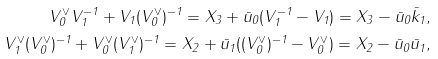<formula> <loc_0><loc_0><loc_500><loc_500>V _ { 0 } ^ { \vee } V _ { 1 } ^ { - 1 } + V _ { 1 } ( V _ { 0 } ^ { \vee } ) ^ { - 1 } = X _ { 3 } + \bar { u } _ { 0 } ( V _ { 1 } ^ { - 1 } - V _ { 1 } ) = X _ { 3 } - \bar { u } _ { 0 } \bar { k } _ { 1 } , \\ V _ { 1 } ^ { \vee } ( V _ { 0 } ^ { \vee } ) ^ { - 1 } + V _ { 0 } ^ { \vee } ( V _ { 1 } ^ { \vee } ) ^ { - 1 } = X _ { 2 } + \bar { u } _ { 1 } ( ( V _ { 0 } ^ { \vee } ) ^ { - 1 } - V _ { 0 } ^ { \vee } ) = X _ { 2 } - \bar { u } _ { 0 } \bar { u } _ { 1 } ,</formula> 